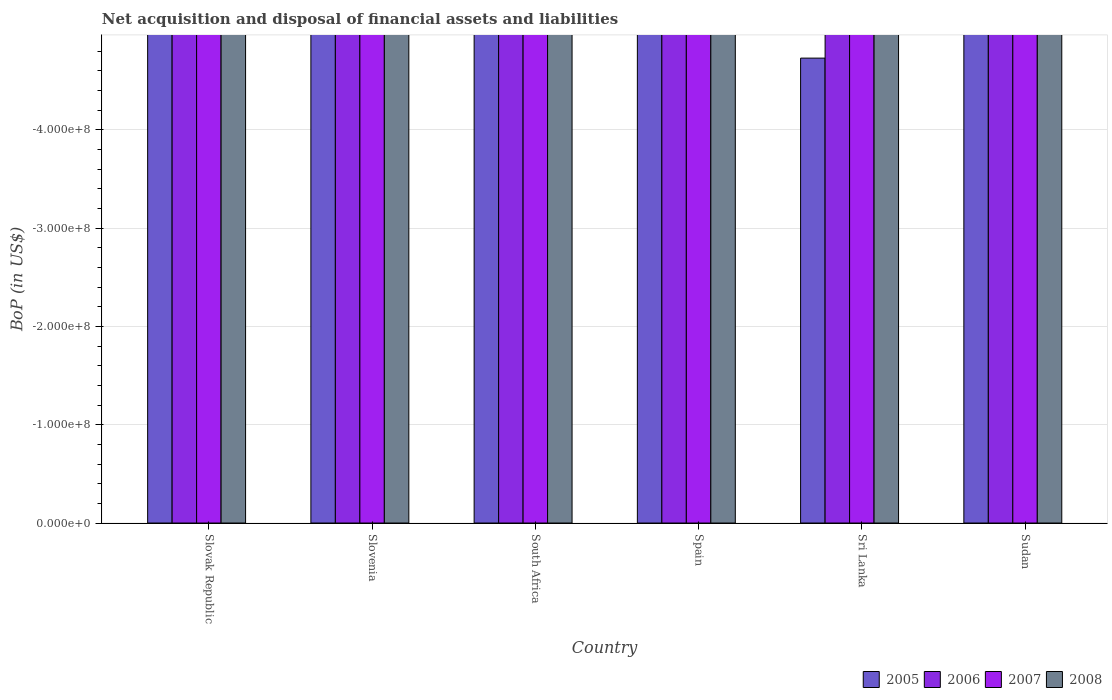What is the label of the 4th group of bars from the left?
Make the answer very short. Spain. What is the Balance of Payments in 2008 in Slovenia?
Your answer should be compact. 0. Across all countries, what is the minimum Balance of Payments in 2006?
Give a very brief answer. 0. What is the total Balance of Payments in 2008 in the graph?
Make the answer very short. 0. In how many countries, is the Balance of Payments in 2005 greater than the average Balance of Payments in 2005 taken over all countries?
Provide a short and direct response. 0. How many bars are there?
Keep it short and to the point. 0. Are the values on the major ticks of Y-axis written in scientific E-notation?
Give a very brief answer. Yes. Does the graph contain any zero values?
Provide a succinct answer. Yes. Where does the legend appear in the graph?
Offer a terse response. Bottom right. How are the legend labels stacked?
Offer a terse response. Horizontal. What is the title of the graph?
Keep it short and to the point. Net acquisition and disposal of financial assets and liabilities. What is the label or title of the X-axis?
Provide a succinct answer. Country. What is the label or title of the Y-axis?
Your response must be concise. BoP (in US$). What is the BoP (in US$) in 2005 in Slovak Republic?
Ensure brevity in your answer.  0. What is the BoP (in US$) in 2007 in Slovak Republic?
Your response must be concise. 0. What is the BoP (in US$) in 2007 in Slovenia?
Make the answer very short. 0. What is the BoP (in US$) in 2008 in Slovenia?
Ensure brevity in your answer.  0. What is the BoP (in US$) in 2005 in South Africa?
Give a very brief answer. 0. What is the BoP (in US$) in 2006 in South Africa?
Keep it short and to the point. 0. What is the BoP (in US$) of 2005 in Sri Lanka?
Give a very brief answer. 0. What is the BoP (in US$) in 2006 in Sri Lanka?
Your answer should be very brief. 0. What is the BoP (in US$) in 2005 in Sudan?
Make the answer very short. 0. What is the BoP (in US$) in 2006 in Sudan?
Ensure brevity in your answer.  0. What is the BoP (in US$) in 2007 in Sudan?
Your response must be concise. 0. What is the BoP (in US$) in 2008 in Sudan?
Your response must be concise. 0. What is the total BoP (in US$) in 2006 in the graph?
Your response must be concise. 0. What is the total BoP (in US$) of 2007 in the graph?
Your answer should be compact. 0. What is the average BoP (in US$) in 2006 per country?
Provide a short and direct response. 0. What is the average BoP (in US$) in 2007 per country?
Your answer should be very brief. 0. What is the average BoP (in US$) in 2008 per country?
Offer a terse response. 0. 